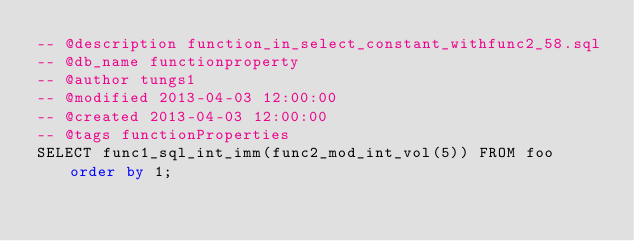Convert code to text. <code><loc_0><loc_0><loc_500><loc_500><_SQL_>-- @description function_in_select_constant_withfunc2_58.sql
-- @db_name functionproperty
-- @author tungs1
-- @modified 2013-04-03 12:00:00
-- @created 2013-04-03 12:00:00
-- @tags functionProperties 
SELECT func1_sql_int_imm(func2_mod_int_vol(5)) FROM foo order by 1; 
</code> 